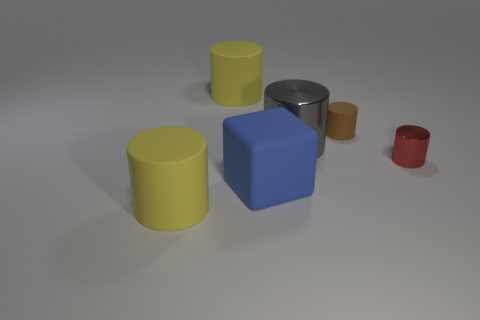What does the arrangement of these objects convey? The arrangement of these objects, with varying sizes and colors, placed seemingly at random on a flat surface, may suggest a study in perspective and scale. This minimalist setup, often used in 3D modeling and rendering demos, emphasizes the shapes and the interplay of light and shadow. It could also symbolize the diversity in uniformity, showing how objects of similar shapes can vary in size and color, hinting at the idea of individuality within a group. 